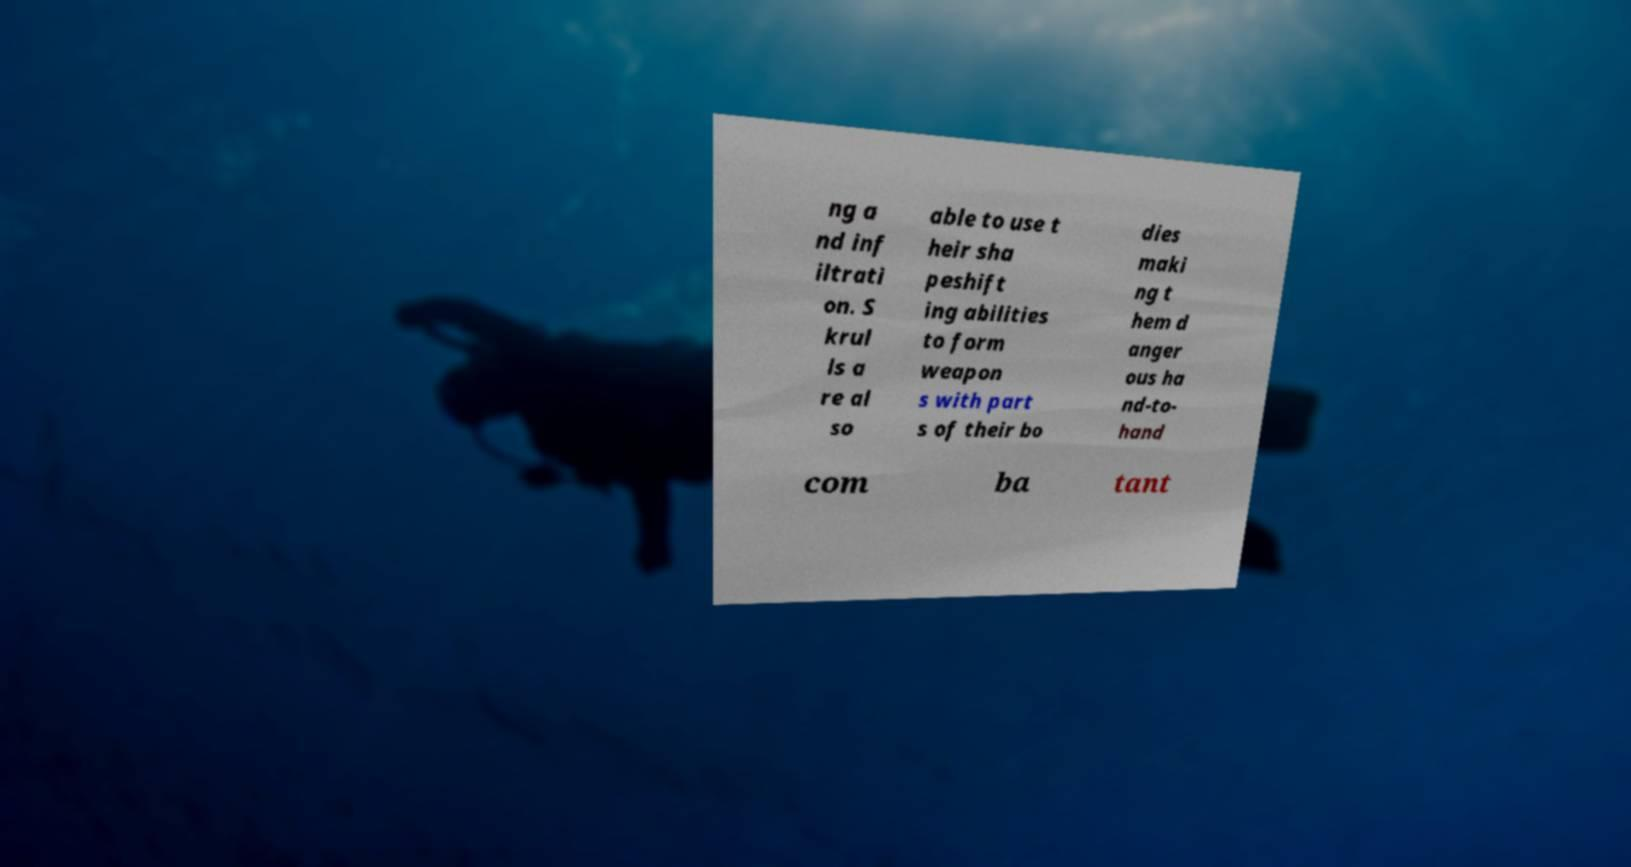I need the written content from this picture converted into text. Can you do that? ng a nd inf iltrati on. S krul ls a re al so able to use t heir sha peshift ing abilities to form weapon s with part s of their bo dies maki ng t hem d anger ous ha nd-to- hand com ba tant 